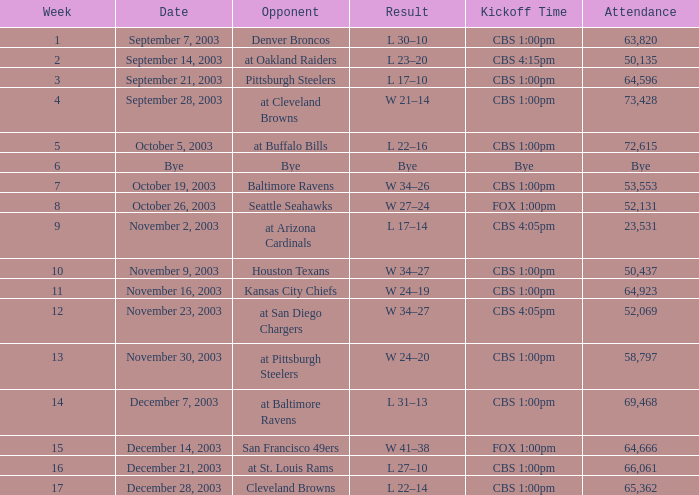At what time did week 1's kickoff occur? CBS 1:00pm. 